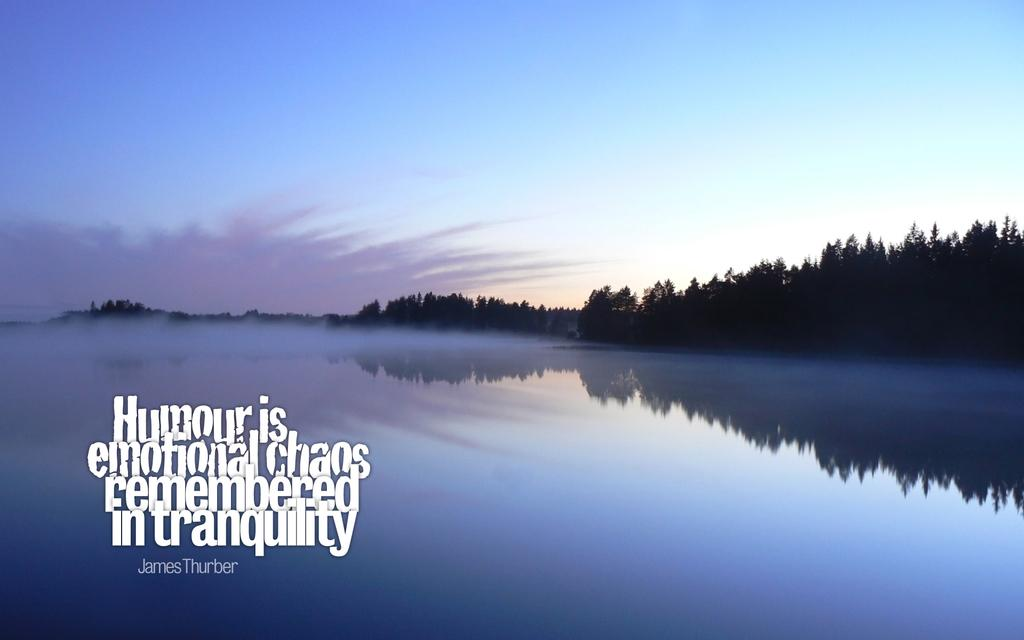What can be seen in the foreground of the picture? In the foreground of the picture, there is text, a water body, and smoke. What type of vegetation is visible in the background of the picture? Trees can be seen in the background of the picture. What is visible at the top of the image? The sky is visible at the top of the image. How many nests can be seen in the trees in the background of the image? There are no nests visible in the trees in the background of the image. Are there any tents set up near the water body in the foreground of the image? There is no mention of tents in the image; only text, a water body, and smoke are visible in the foreground. 